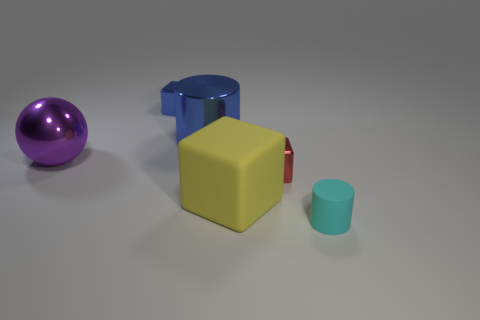Add 3 big green matte things. How many objects exist? 9 Subtract all tiny blocks. How many blocks are left? 1 Add 3 large blue objects. How many large blue objects are left? 4 Add 2 big things. How many big things exist? 5 Subtract all blue cubes. How many cubes are left? 2 Subtract 1 blue cylinders. How many objects are left? 5 Subtract all spheres. How many objects are left? 5 Subtract 1 blocks. How many blocks are left? 2 Subtract all blue cubes. Subtract all red cylinders. How many cubes are left? 2 Subtract all purple cylinders. How many green spheres are left? 0 